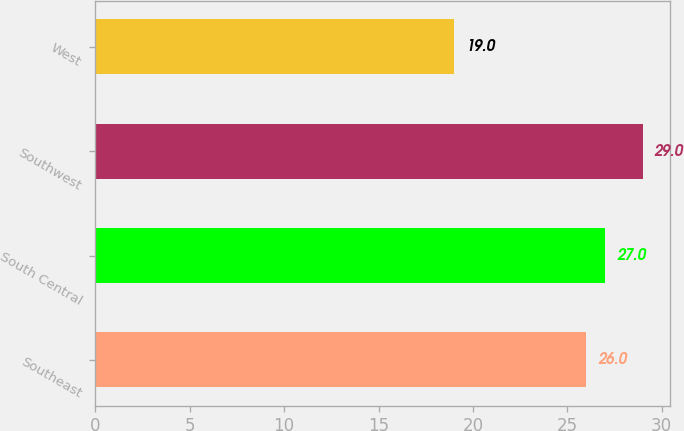Convert chart. <chart><loc_0><loc_0><loc_500><loc_500><bar_chart><fcel>Southeast<fcel>South Central<fcel>Southwest<fcel>West<nl><fcel>26<fcel>27<fcel>29<fcel>19<nl></chart> 